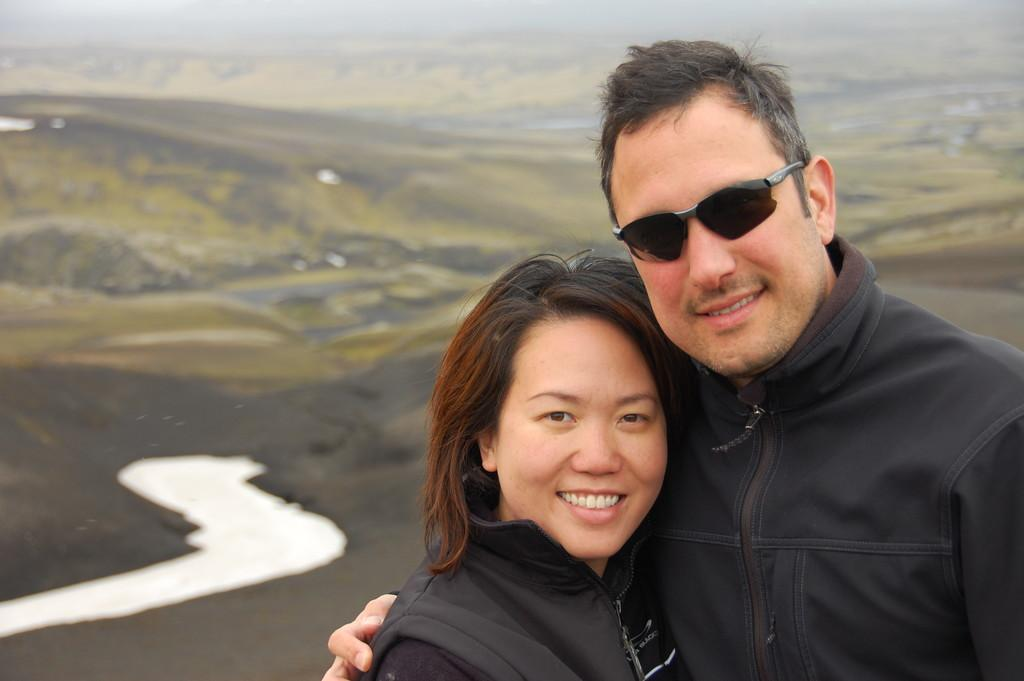How many people are in the image? There are two women in the image. What are the women doing in the image? Both women are standing and smiling. Can you describe the background of the image? The background of the image is blurred. What type of thread is being used by the women in the image? There is no thread present in the image; the women are simply standing and smiling. 